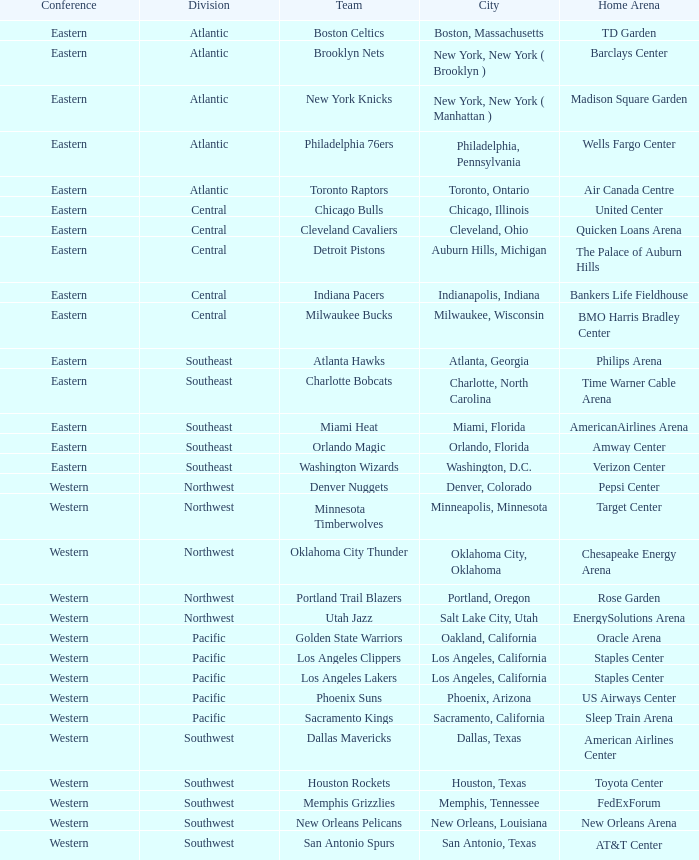Which team is located in the southeast and has a home at philips arena? Atlanta Hawks. 